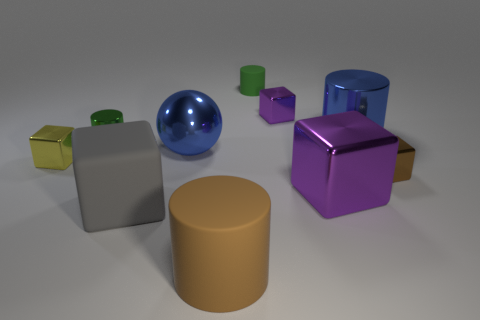Does the ball have the same color as the large rubber cylinder?
Provide a succinct answer. No. Are there fewer yellow blocks that are right of the large purple metal cube than red metallic things?
Give a very brief answer. No. What material is the other small cylinder that is the same color as the small rubber cylinder?
Offer a terse response. Metal. Does the tiny yellow thing have the same material as the blue cylinder?
Your response must be concise. Yes. What number of other large cylinders are the same material as the brown cylinder?
Ensure brevity in your answer.  0. What color is the big thing that is the same material as the big gray cube?
Give a very brief answer. Brown. What is the shape of the large gray rubber object?
Make the answer very short. Cube. What material is the large cylinder that is behind the brown shiny block?
Make the answer very short. Metal. Are there any rubber cylinders of the same color as the ball?
Make the answer very short. No. What is the shape of the gray matte object that is the same size as the brown cylinder?
Keep it short and to the point. Cube. 